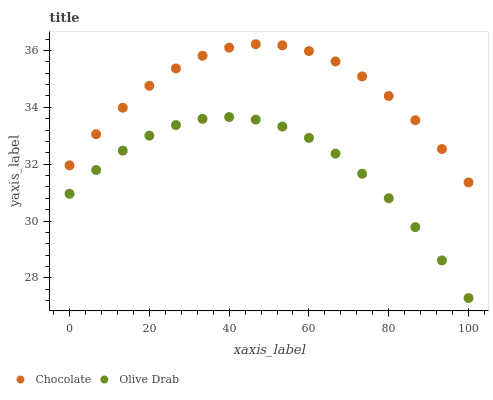Does Olive Drab have the minimum area under the curve?
Answer yes or no. Yes. Does Chocolate have the maximum area under the curve?
Answer yes or no. Yes. Does Chocolate have the minimum area under the curve?
Answer yes or no. No. Is Olive Drab the smoothest?
Answer yes or no. Yes. Is Chocolate the roughest?
Answer yes or no. Yes. Is Chocolate the smoothest?
Answer yes or no. No. Does Olive Drab have the lowest value?
Answer yes or no. Yes. Does Chocolate have the lowest value?
Answer yes or no. No. Does Chocolate have the highest value?
Answer yes or no. Yes. Is Olive Drab less than Chocolate?
Answer yes or no. Yes. Is Chocolate greater than Olive Drab?
Answer yes or no. Yes. Does Olive Drab intersect Chocolate?
Answer yes or no. No. 